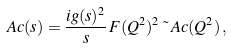Convert formula to latex. <formula><loc_0><loc_0><loc_500><loc_500>\ A c ( s ) = \frac { i g ( s ) ^ { 2 } } { s } \, F ( Q ^ { 2 } ) ^ { 2 } \, \tilde { \ } A c ( Q ^ { 2 } ) \, ,</formula> 